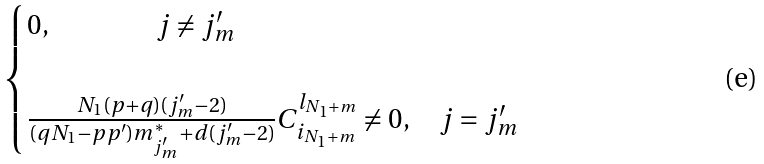<formula> <loc_0><loc_0><loc_500><loc_500>\begin{cases} 0 , \quad \ \quad \ \quad \ \ j \neq j ^ { \prime } _ { m } \\ \\ \frac { N _ { 1 } ( p + q ) ( j ^ { \prime } _ { m } - 2 ) } { ( q N _ { 1 } - p p ^ { \prime } ) m ^ { * } _ { j ^ { \prime } _ { m } } + d ( j ^ { \prime } _ { m } - 2 ) } C ^ { l _ { N _ { 1 } + m } } _ { i _ { N _ { 1 } + m } } \neq 0 , \quad j = j ^ { \prime } _ { m } \end{cases}</formula> 